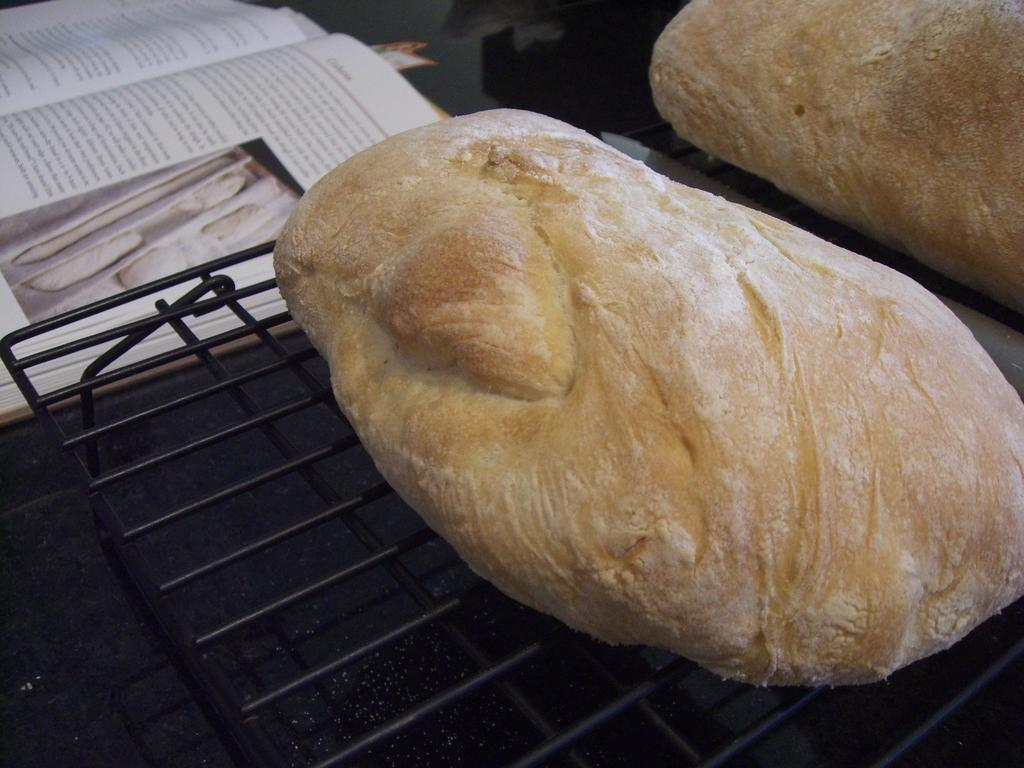What is placed on the table in the image? There is dough placed on a table in the image. What else can be seen in the image besides the dough? There is a book visible in the image. What type of jewel is being used to mix the dough in the image? There is no jewel present in the image; it is dough placed on a table. 